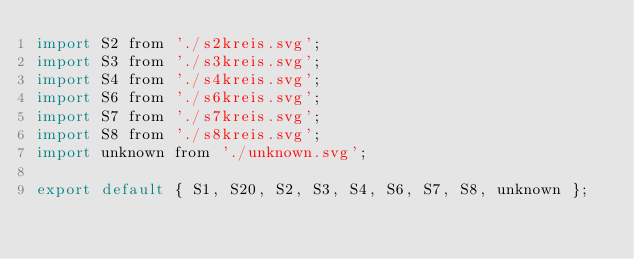Convert code to text. <code><loc_0><loc_0><loc_500><loc_500><_JavaScript_>import S2 from './s2kreis.svg';
import S3 from './s3kreis.svg';
import S4 from './s4kreis.svg';
import S6 from './s6kreis.svg';
import S7 from './s7kreis.svg';
import S8 from './s8kreis.svg';
import unknown from './unknown.svg';

export default { S1, S20, S2, S3, S4, S6, S7, S8, unknown };
</code> 